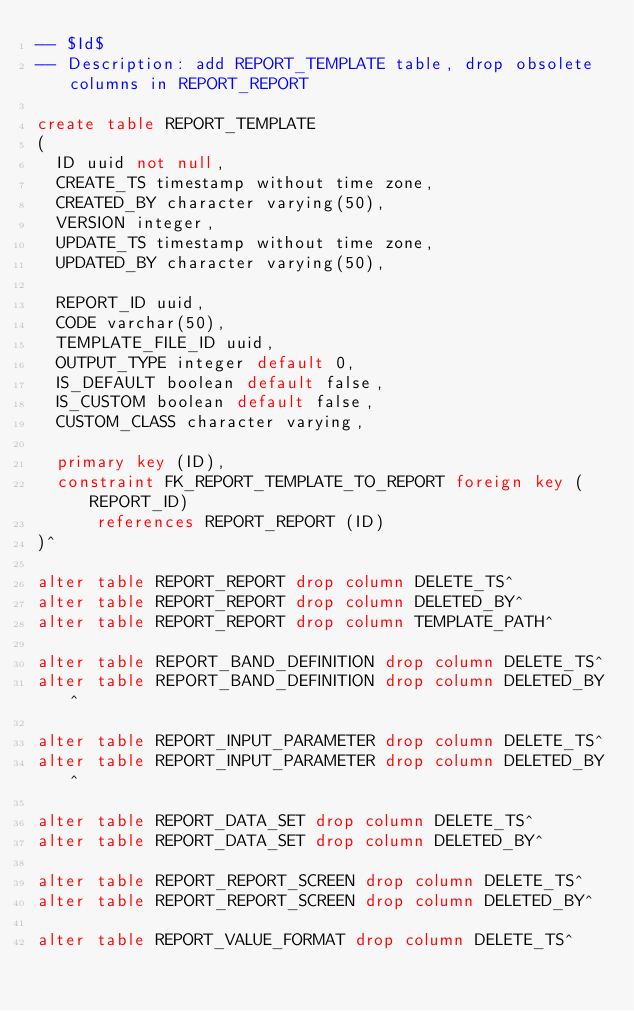<code> <loc_0><loc_0><loc_500><loc_500><_SQL_>-- $Id$
-- Description: add REPORT_TEMPLATE table, drop obsolete columns in REPORT_REPORT

create table REPORT_TEMPLATE
(
  ID uuid not null,
  CREATE_TS timestamp without time zone,
  CREATED_BY character varying(50),
  VERSION integer,
  UPDATE_TS timestamp without time zone,
  UPDATED_BY character varying(50),

  REPORT_ID uuid,
  CODE varchar(50),
  TEMPLATE_FILE_ID uuid,
  OUTPUT_TYPE integer default 0,
  IS_DEFAULT boolean default false,
  IS_CUSTOM boolean default false,
  CUSTOM_CLASS character varying,

  primary key (ID),
  constraint FK_REPORT_TEMPLATE_TO_REPORT foreign key (REPORT_ID)
      references REPORT_REPORT (ID)
)^

alter table REPORT_REPORT drop column DELETE_TS^
alter table REPORT_REPORT drop column DELETED_BY^
alter table REPORT_REPORT drop column TEMPLATE_PATH^

alter table REPORT_BAND_DEFINITION drop column DELETE_TS^
alter table REPORT_BAND_DEFINITION drop column DELETED_BY^

alter table REPORT_INPUT_PARAMETER drop column DELETE_TS^
alter table REPORT_INPUT_PARAMETER drop column DELETED_BY^

alter table REPORT_DATA_SET drop column DELETE_TS^
alter table REPORT_DATA_SET drop column DELETED_BY^

alter table REPORT_REPORT_SCREEN drop column DELETE_TS^
alter table REPORT_REPORT_SCREEN drop column DELETED_BY^

alter table REPORT_VALUE_FORMAT drop column DELETE_TS^</code> 